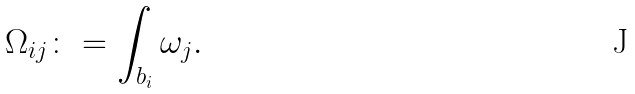Convert formula to latex. <formula><loc_0><loc_0><loc_500><loc_500>\Omega _ { i j } \colon = \int _ { b _ { i } } \omega _ { j } .</formula> 